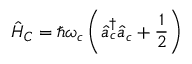<formula> <loc_0><loc_0><loc_500><loc_500>\hat { H } _ { C } = \hbar { \omega } _ { c } \left ( \hat { a } _ { c } ^ { \dagger } \hat { a } _ { c } + \frac { 1 } { 2 } \right )</formula> 